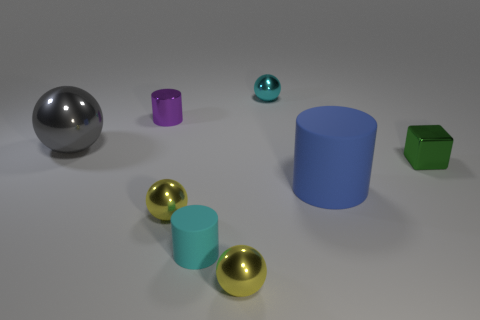What number of other things are there of the same size as the cyan metallic object?
Ensure brevity in your answer.  5. What size is the purple thing that is the same shape as the large blue rubber object?
Your answer should be very brief. Small. The small cyan shiny object that is to the right of the purple metal cylinder has what shape?
Provide a short and direct response. Sphere. There is a small shiny ball that is in front of the rubber cylinder that is in front of the blue object; what color is it?
Give a very brief answer. Yellow. How many things are tiny spheres in front of the gray shiny sphere or tiny purple shiny things?
Offer a very short reply. 3. Is the size of the blue matte cylinder the same as the cylinder behind the small green block?
Provide a short and direct response. No. How many big things are spheres or green objects?
Ensure brevity in your answer.  1. What shape is the large rubber thing?
Provide a succinct answer. Cylinder. There is another object that is the same color as the small matte object; what is its size?
Offer a terse response. Small. Is there a large brown cylinder that has the same material as the tiny cube?
Keep it short and to the point. No. 